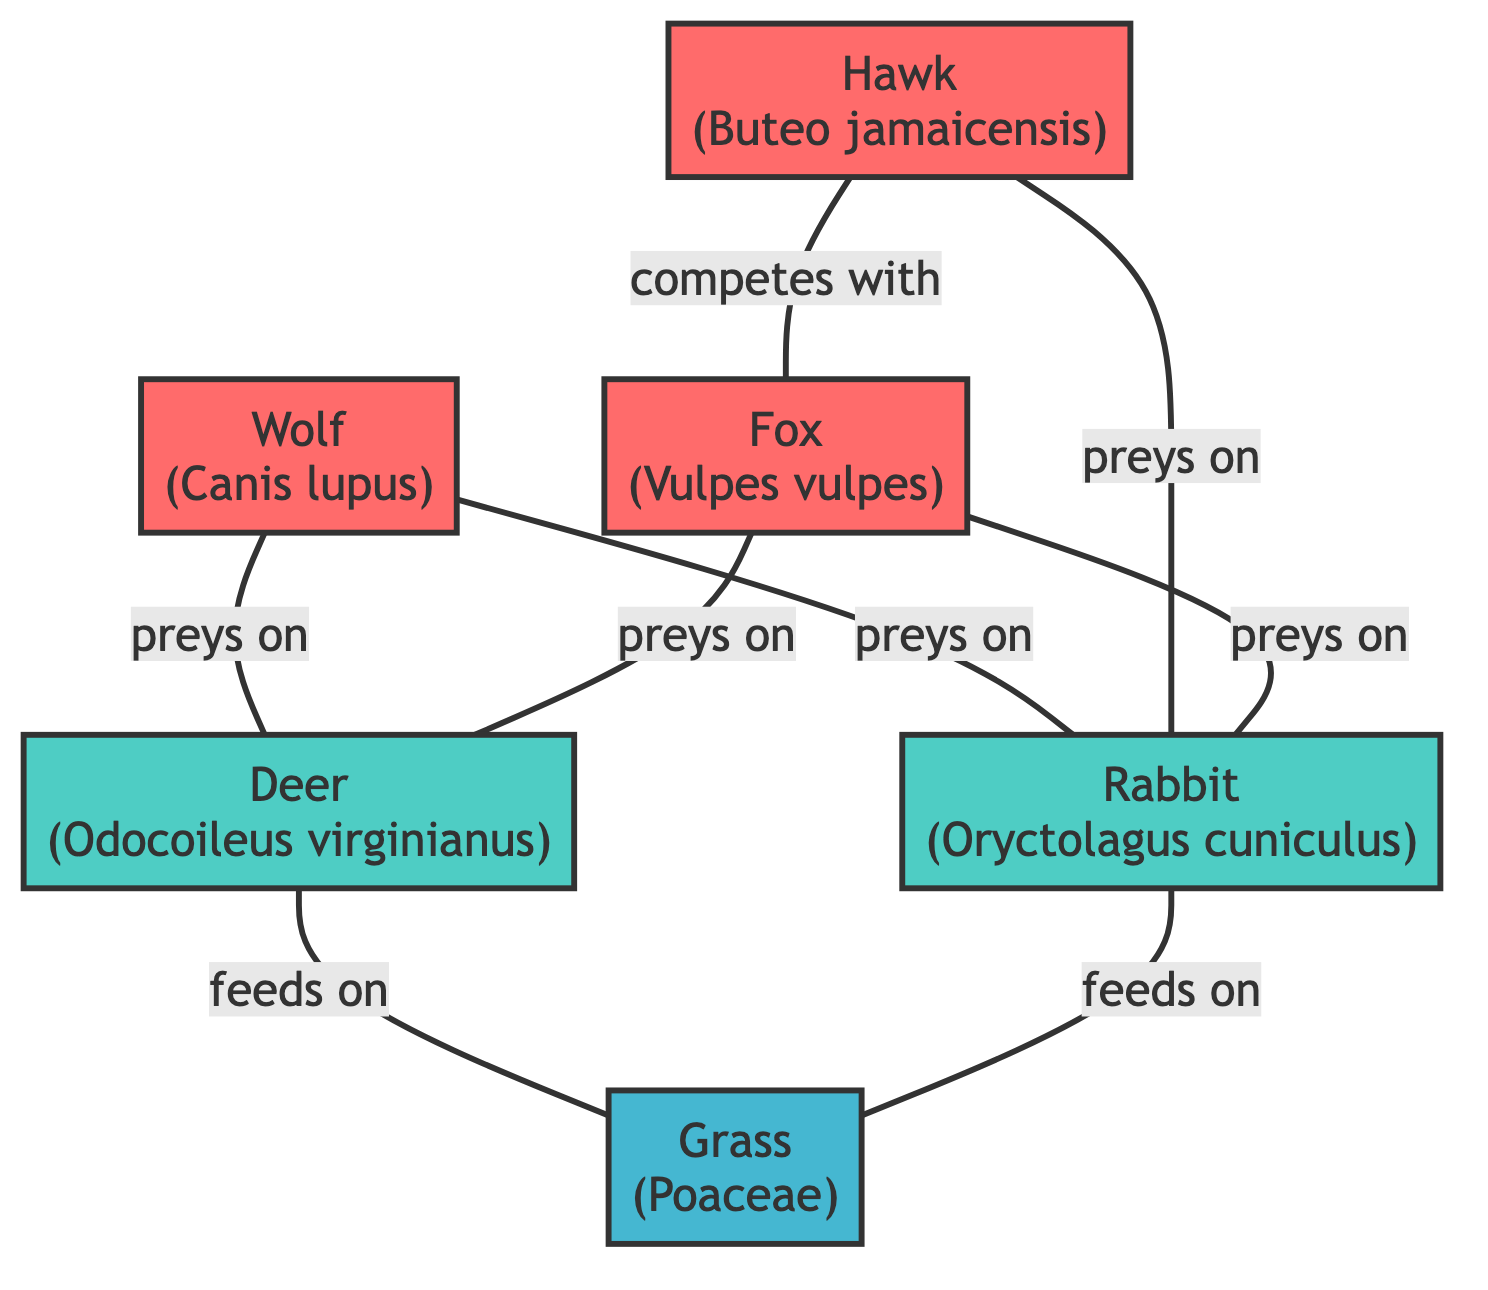What is the total number of species represented in the diagram? The diagram has six nodes, each representing a different species in the ecosystem, namely Wolf, Deer, Rabbit, Grass, Hawk, and Fox.
Answer: 6 Which animal is the primary predator of the Rabbit? The edge labeled "preys on" connecting the Hawk and Rabbit indicates that the Hawk primarily preys on the Rabbit. This is also confirmed by the other edges showing that the Wolf and Fox also prey on the Rabbit.
Answer: Hawk How many herbivores are shown in the diagram? The nodes for the Deer and Rabbit are classified as herbivores. Since there are only two herbivores represented, the answer is two.
Answer: 2 What interaction exists between the Fox and Deer? According to the edge connecting the Fox and Deer, the interaction listed is "preys on," indicating that the Fox preys on the Deer.
Answer: preys on Which species feeds on Grass in the ecosystem? The Deer and Rabbit both have edges labeled "feeds on" connecting them to the Grass node, indicating they consume it as part of their diet.
Answer: Deer, Rabbit Which two carnivores are shown to compete with each other? The edge labeled "competes with" connects the Hawk and Fox, indicating that these two carnivores compete within the ecosystem.
Answer: Hawk, Fox How many edges are there representing predatory interactions? There are four edges in total illustrating predatory relationships: Wolf to Deer, Wolf to Rabbit, Hawk to Rabbit, and Fox to Rabbit and Deer. Counting these gives a total of four predatory interactions.
Answer: 5 Which animal interacts the most with the Rabbit? The Rabbit has interactions with three different carnivores: the Wolf, Fox, and Hawk, indicating it is a primary calorie source for these animals.
Answer: Wolf, Fox, Hawk Which species is the only producer represented in the graph? The Grass node is labeled as a "Producer," identifying it as the sole producer in this ecosystem, providing energy for herbivores.
Answer: Grass 